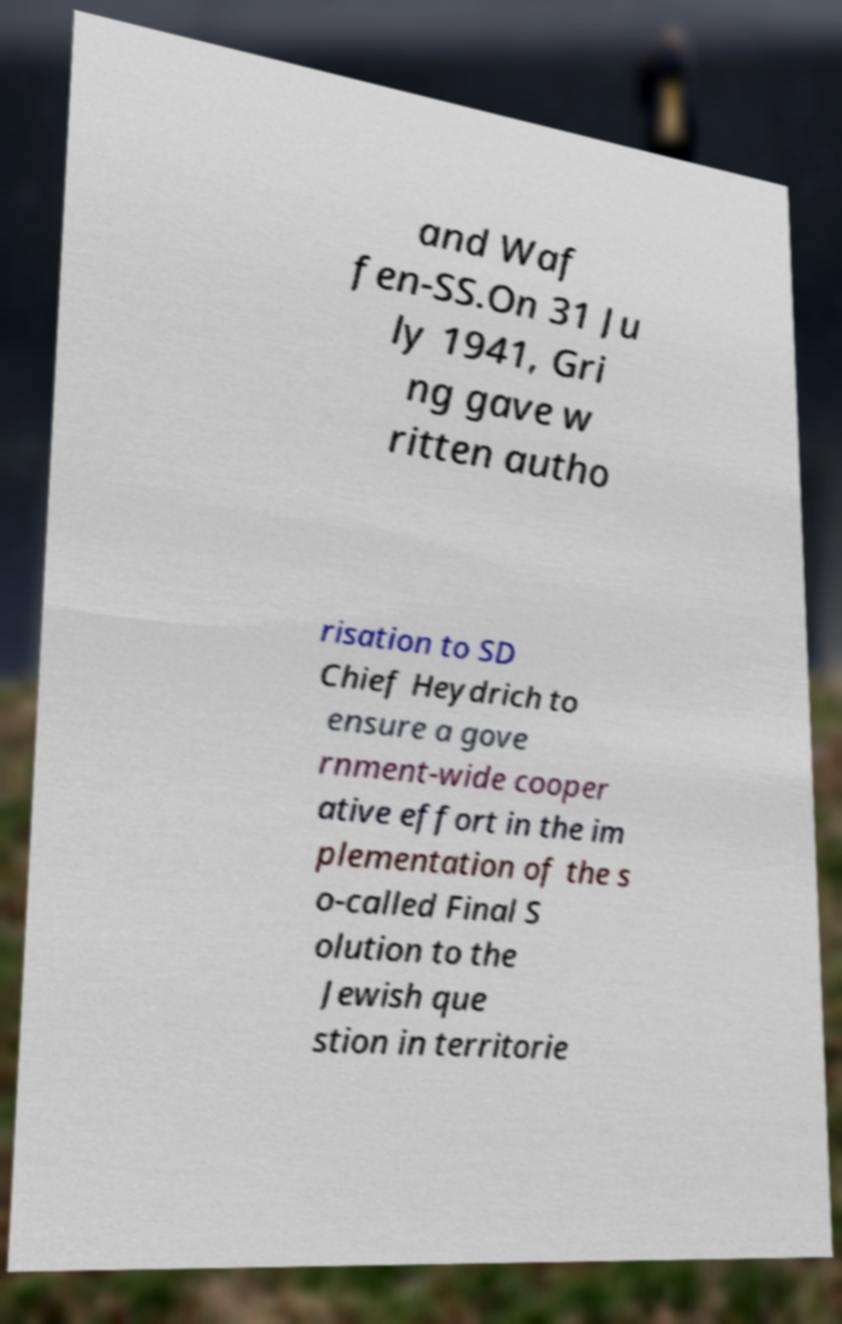For documentation purposes, I need the text within this image transcribed. Could you provide that? and Waf fen-SS.On 31 Ju ly 1941, Gri ng gave w ritten autho risation to SD Chief Heydrich to ensure a gove rnment-wide cooper ative effort in the im plementation of the s o-called Final S olution to the Jewish que stion in territorie 